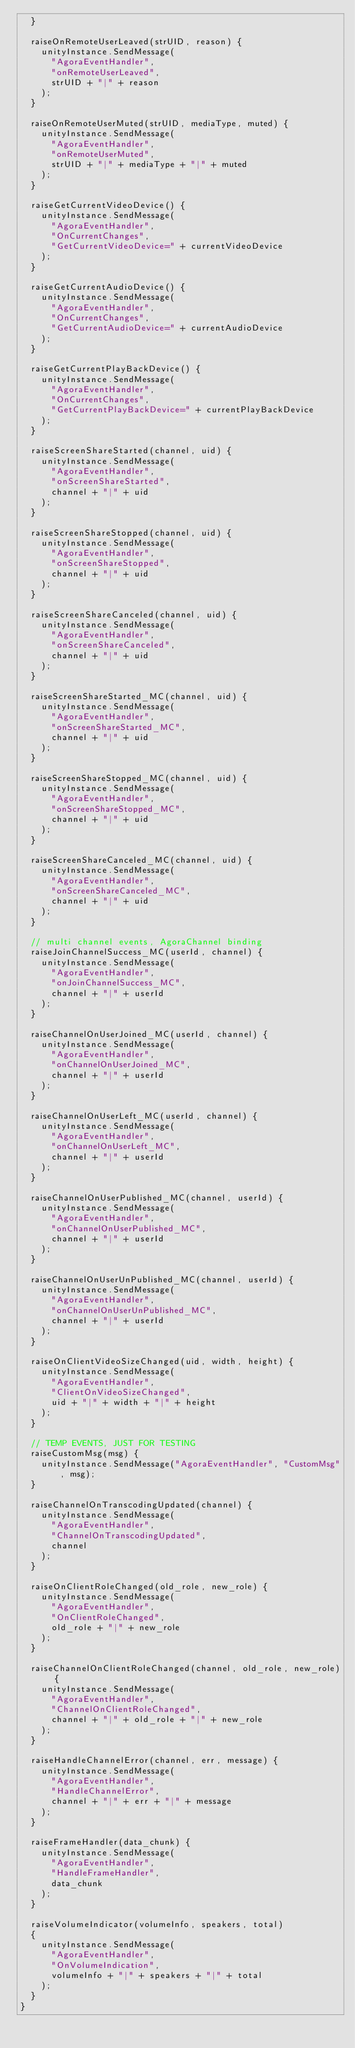<code> <loc_0><loc_0><loc_500><loc_500><_JavaScript_>  }

  raiseOnRemoteUserLeaved(strUID, reason) {
    unityInstance.SendMessage(
      "AgoraEventHandler",
      "onRemoteUserLeaved",
      strUID + "|" + reason
    );
  }

  raiseOnRemoteUserMuted(strUID, mediaType, muted) {
    unityInstance.SendMessage(
      "AgoraEventHandler",
      "onRemoteUserMuted",
      strUID + "|" + mediaType + "|" + muted
    ); 
  }

  raiseGetCurrentVideoDevice() {
    unityInstance.SendMessage(
      "AgoraEventHandler",
      "OnCurrentChanges",
      "GetCurrentVideoDevice=" + currentVideoDevice
    );
  }

  raiseGetCurrentAudioDevice() {
    unityInstance.SendMessage(
      "AgoraEventHandler",
      "OnCurrentChanges",
      "GetCurrentAudioDevice=" + currentAudioDevice
    );
  }

  raiseGetCurrentPlayBackDevice() {
    unityInstance.SendMessage(
      "AgoraEventHandler",
      "OnCurrentChanges",
      "GetCurrentPlayBackDevice=" + currentPlayBackDevice
    );
  }

  raiseScreenShareStarted(channel, uid) {
    unityInstance.SendMessage(
      "AgoraEventHandler",
      "onScreenShareStarted",
      channel + "|" + uid
    );
  }

  raiseScreenShareStopped(channel, uid) {
    unityInstance.SendMessage(
      "AgoraEventHandler",
      "onScreenShareStopped",
      channel + "|" + uid
    );
  }

  raiseScreenShareCanceled(channel, uid) {
    unityInstance.SendMessage(
      "AgoraEventHandler",
      "onScreenShareCanceled",
      channel + "|" + uid
    );
  }

  raiseScreenShareStarted_MC(channel, uid) {
    unityInstance.SendMessage(
      "AgoraEventHandler",
      "onScreenShareStarted_MC",
      channel + "|" + uid
    );
  }

  raiseScreenShareStopped_MC(channel, uid) {
    unityInstance.SendMessage(
      "AgoraEventHandler",
      "onScreenShareStopped_MC",
      channel + "|" + uid
    );
  }

  raiseScreenShareCanceled_MC(channel, uid) {
    unityInstance.SendMessage(
      "AgoraEventHandler",
      "onScreenShareCanceled_MC",
      channel + "|" + uid
    );
  }

  // multi channel events, AgoraChannel binding
  raiseJoinChannelSuccess_MC(userId, channel) {
    unityInstance.SendMessage(
      "AgoraEventHandler",
      "onJoinChannelSuccess_MC",
      channel + "|" + userId
    );
  }

  raiseChannelOnUserJoined_MC(userId, channel) {
    unityInstance.SendMessage(
      "AgoraEventHandler",
      "onChannelOnUserJoined_MC",
      channel + "|" + userId
    );
  }

  raiseChannelOnUserLeft_MC(userId, channel) {
    unityInstance.SendMessage(
      "AgoraEventHandler",
      "onChannelOnUserLeft_MC",
      channel + "|" + userId
    );
  }

  raiseChannelOnUserPublished_MC(channel, userId) {
    unityInstance.SendMessage(
      "AgoraEventHandler",
      "onChannelOnUserPublished_MC",
      channel + "|" + userId
    );
  }

  raiseChannelOnUserUnPublished_MC(channel, userId) {
    unityInstance.SendMessage(
      "AgoraEventHandler",
      "onChannelOnUserUnPublished_MC",
      channel + "|" + userId
    );
  }

  raiseOnClientVideoSizeChanged(uid, width, height) {
    unityInstance.SendMessage(
      "AgoraEventHandler",
      "ClientOnVideoSizeChanged",
      uid + "|" + width + "|" + height
    );
  }

  // TEMP EVENTS, JUST FOR TESTING
  raiseCustomMsg(msg) {
    unityInstance.SendMessage("AgoraEventHandler", "CustomMsg", msg);
  }

  raiseChannelOnTranscodingUpdated(channel) {
    unityInstance.SendMessage(
      "AgoraEventHandler",
      "ChannelOnTranscodingUpdated",
      channel
    );
  }

  raiseOnClientRoleChanged(old_role, new_role) {
    unityInstance.SendMessage(
      "AgoraEventHandler",
      "OnClientRoleChanged",
      old_role + "|" + new_role
    );
  }

  raiseChannelOnClientRoleChanged(channel, old_role, new_role) {
    unityInstance.SendMessage(
      "AgoraEventHandler",
      "ChannelOnClientRoleChanged",
      channel + "|" + old_role + "|" + new_role
    );
  }

  raiseHandleChannelError(channel, err, message) {
    unityInstance.SendMessage(
      "AgoraEventHandler",
      "HandleChannelError",
      channel + "|" + err + "|" + message
    );
  }

  raiseFrameHandler(data_chunk) {
    unityInstance.SendMessage(
      "AgoraEventHandler",
      "HandleFrameHandler",
      data_chunk
    );
  }

  raiseVolumeIndicator(volumeInfo, speakers, total)
  {
    unityInstance.SendMessage(
      "AgoraEventHandler",
      "OnVolumeIndication",
      volumeInfo + "|" + speakers + "|" + total
    );
  }
}
</code> 